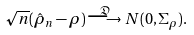<formula> <loc_0><loc_0><loc_500><loc_500>\sqrt { n } ( \hat { \rho } _ { n } - \rho ) \stackrel { \mathfrak { D } } { \longrightarrow } N ( 0 , \Sigma _ { \rho } ) .</formula> 